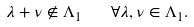Convert formula to latex. <formula><loc_0><loc_0><loc_500><loc_500>\lambda + \nu \not \in \Lambda _ { 1 } \quad \forall \lambda , \nu \in \Lambda _ { 1 } .</formula> 